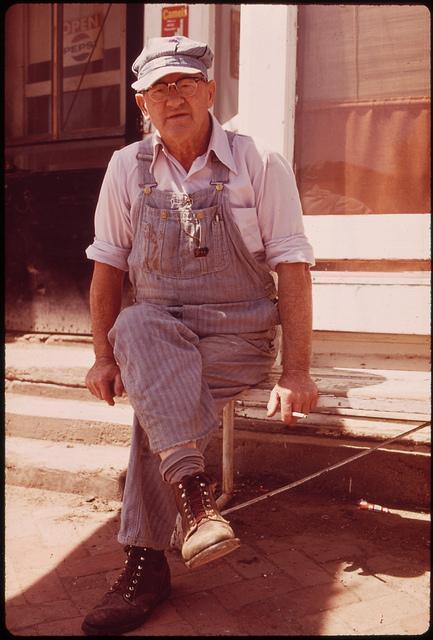How many steps are there?
Give a very brief answer. 3. 